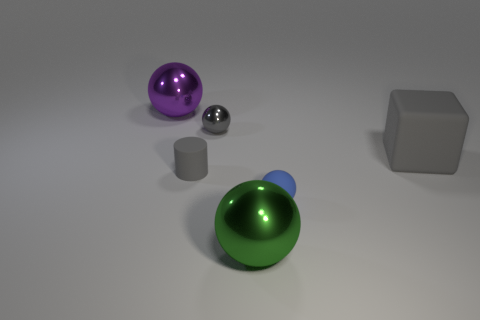What can you say about the lighting and shadows in the image? The image features soft, diffused lighting coming from the upper left, casting gentle shadows to the right of the objects. The lighting highlights the shiny textures of the balls and metal cylinder, and creates a subtle contrast on the matte surface of the cube. 